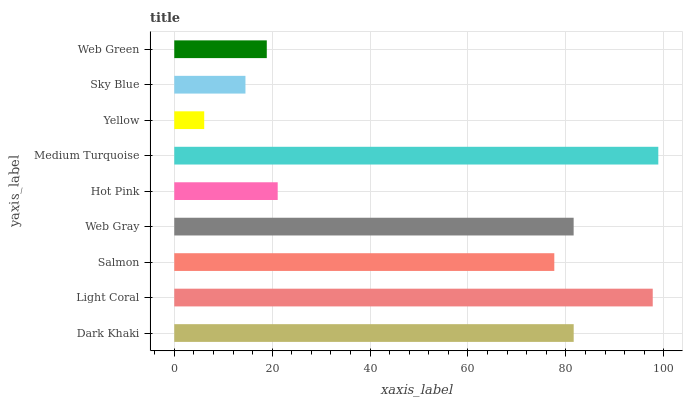Is Yellow the minimum?
Answer yes or no. Yes. Is Medium Turquoise the maximum?
Answer yes or no. Yes. Is Light Coral the minimum?
Answer yes or no. No. Is Light Coral the maximum?
Answer yes or no. No. Is Light Coral greater than Dark Khaki?
Answer yes or no. Yes. Is Dark Khaki less than Light Coral?
Answer yes or no. Yes. Is Dark Khaki greater than Light Coral?
Answer yes or no. No. Is Light Coral less than Dark Khaki?
Answer yes or no. No. Is Salmon the high median?
Answer yes or no. Yes. Is Salmon the low median?
Answer yes or no. Yes. Is Hot Pink the high median?
Answer yes or no. No. Is Dark Khaki the low median?
Answer yes or no. No. 